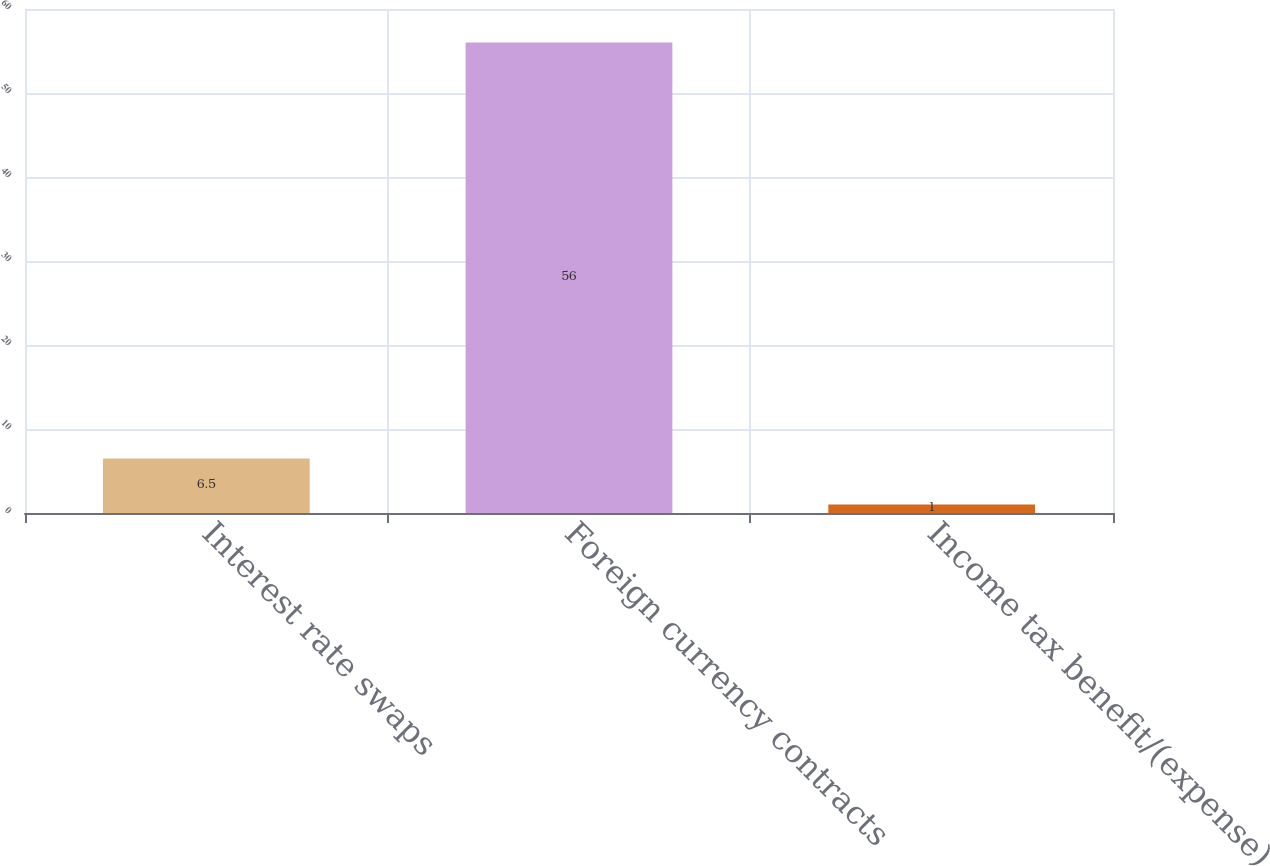Convert chart to OTSL. <chart><loc_0><loc_0><loc_500><loc_500><bar_chart><fcel>Interest rate swaps<fcel>Foreign currency contracts<fcel>Income tax benefit/(expense)<nl><fcel>6.5<fcel>56<fcel>1<nl></chart> 